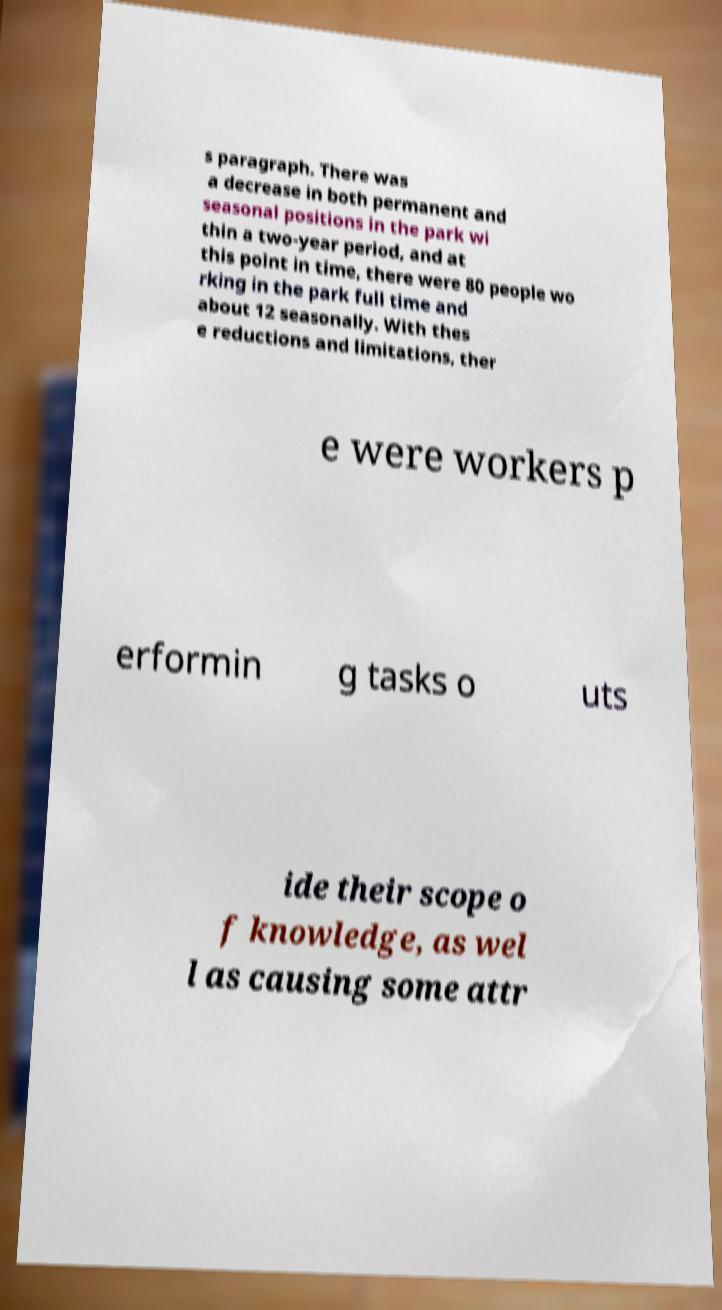I need the written content from this picture converted into text. Can you do that? s paragraph. There was a decrease in both permanent and seasonal positions in the park wi thin a two-year period, and at this point in time, there were 80 people wo rking in the park full time and about 12 seasonally. With thes e reductions and limitations, ther e were workers p erformin g tasks o uts ide their scope o f knowledge, as wel l as causing some attr 